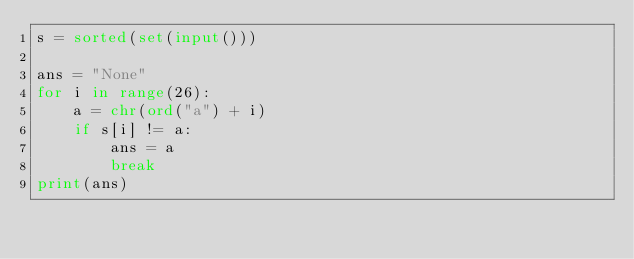<code> <loc_0><loc_0><loc_500><loc_500><_Python_>s = sorted(set(input()))

ans = "None"
for i in range(26):
    a = chr(ord("a") + i)
    if s[i] != a:
        ans = a
        break
print(ans)
</code> 